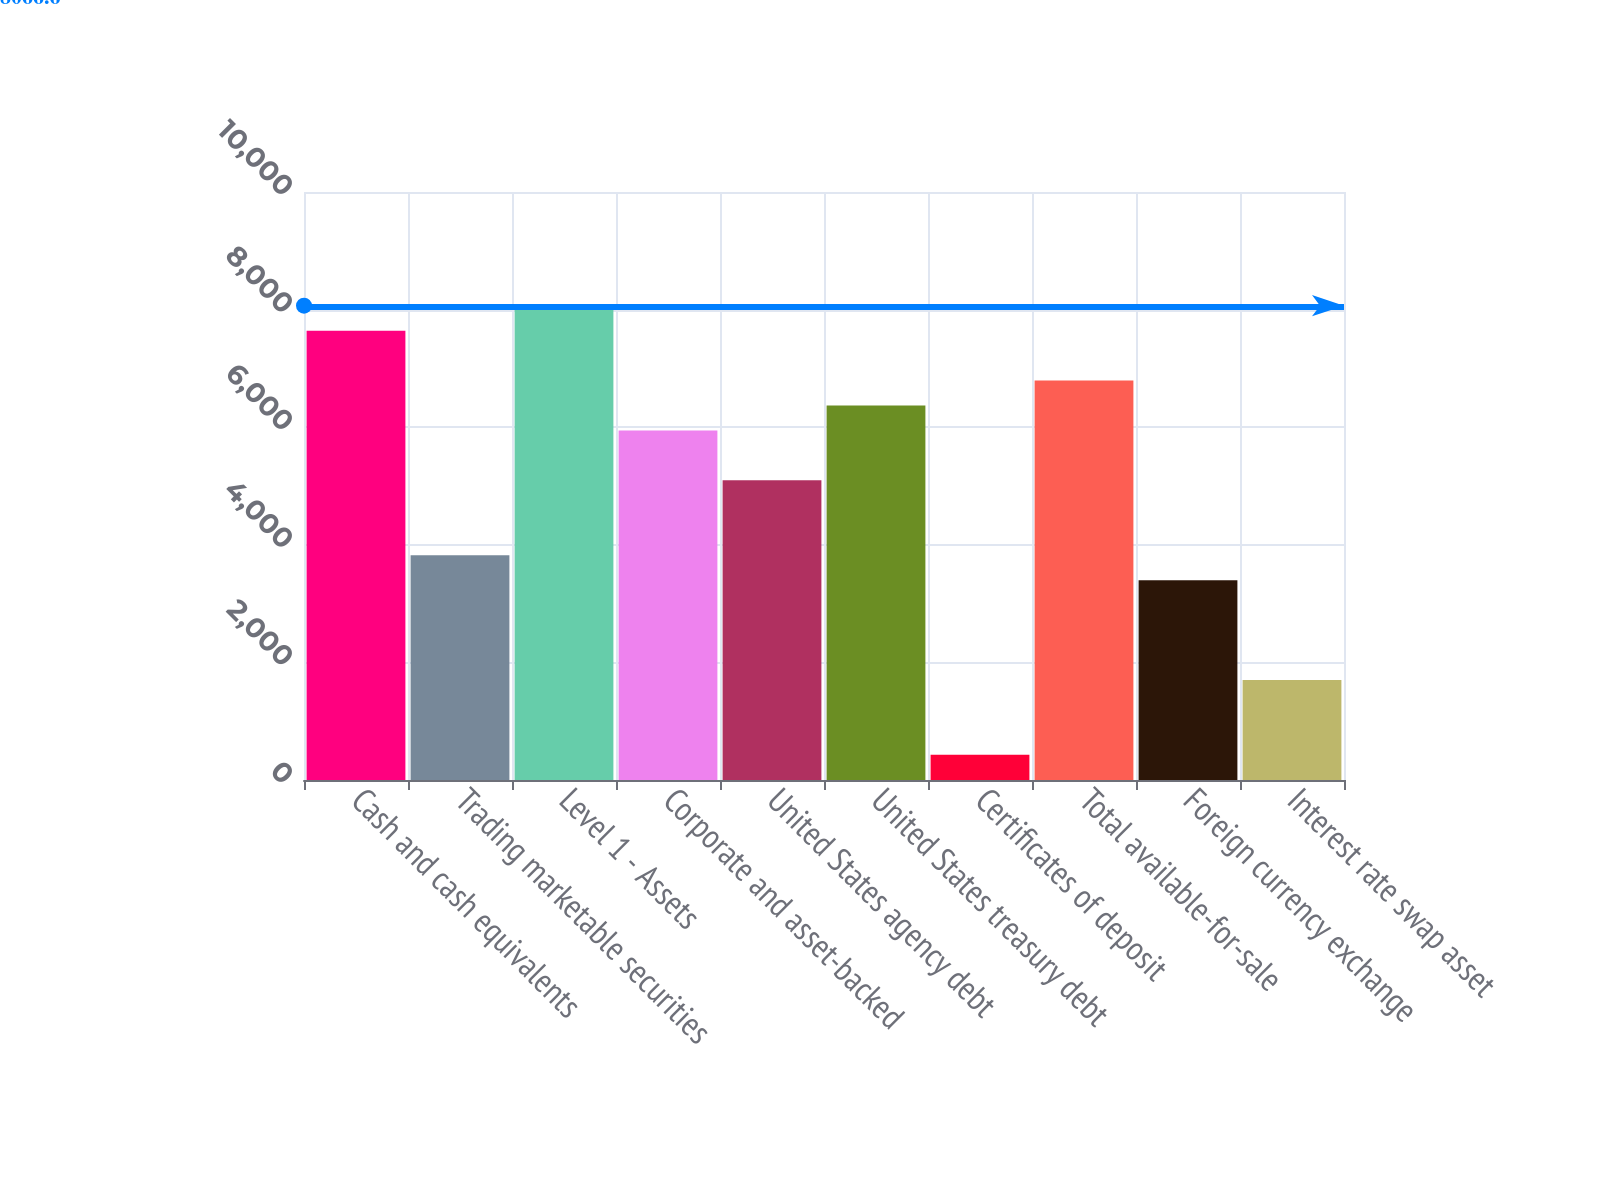Convert chart to OTSL. <chart><loc_0><loc_0><loc_500><loc_500><bar_chart><fcel>Cash and cash equivalents<fcel>Trading marketable securities<fcel>Level 1 - Assets<fcel>Corporate and asset-backed<fcel>United States agency debt<fcel>United States treasury debt<fcel>Certificates of deposit<fcel>Total available-for-sale<fcel>Foreign currency exchange<fcel>Interest rate swap asset<nl><fcel>7642.2<fcel>3822.6<fcel>8066.6<fcel>5944.6<fcel>5095.8<fcel>6369<fcel>427.4<fcel>6793.4<fcel>3398.2<fcel>1700.6<nl></chart> 